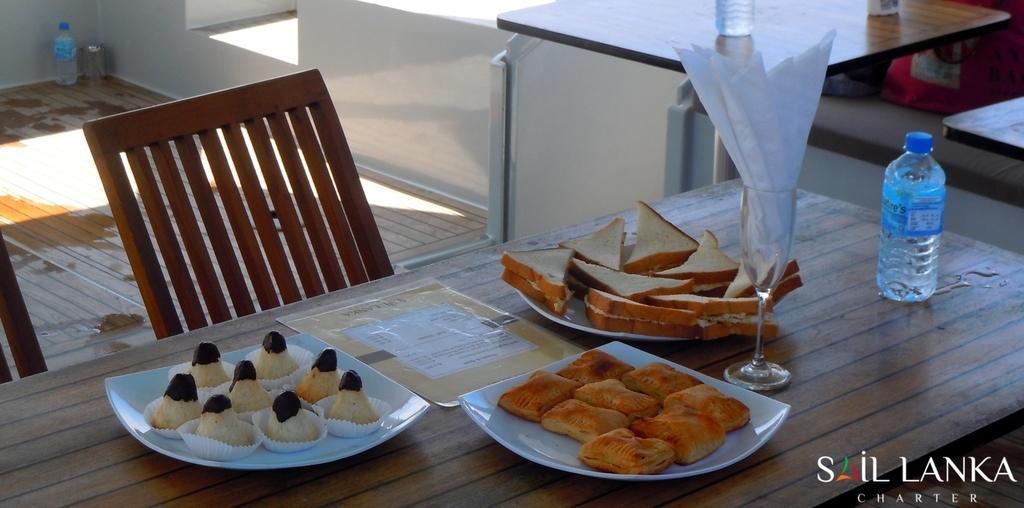How would you summarize this image in a sentence or two? In this picture I can see food in the plates and I can see napkins in the glass and a water bottle on the table and I can see a menu card and couple of chairs and I can see another table and a water bottle on it and I can see a water bottle on the floor and I can see text at the bottom right corner of the picture. 